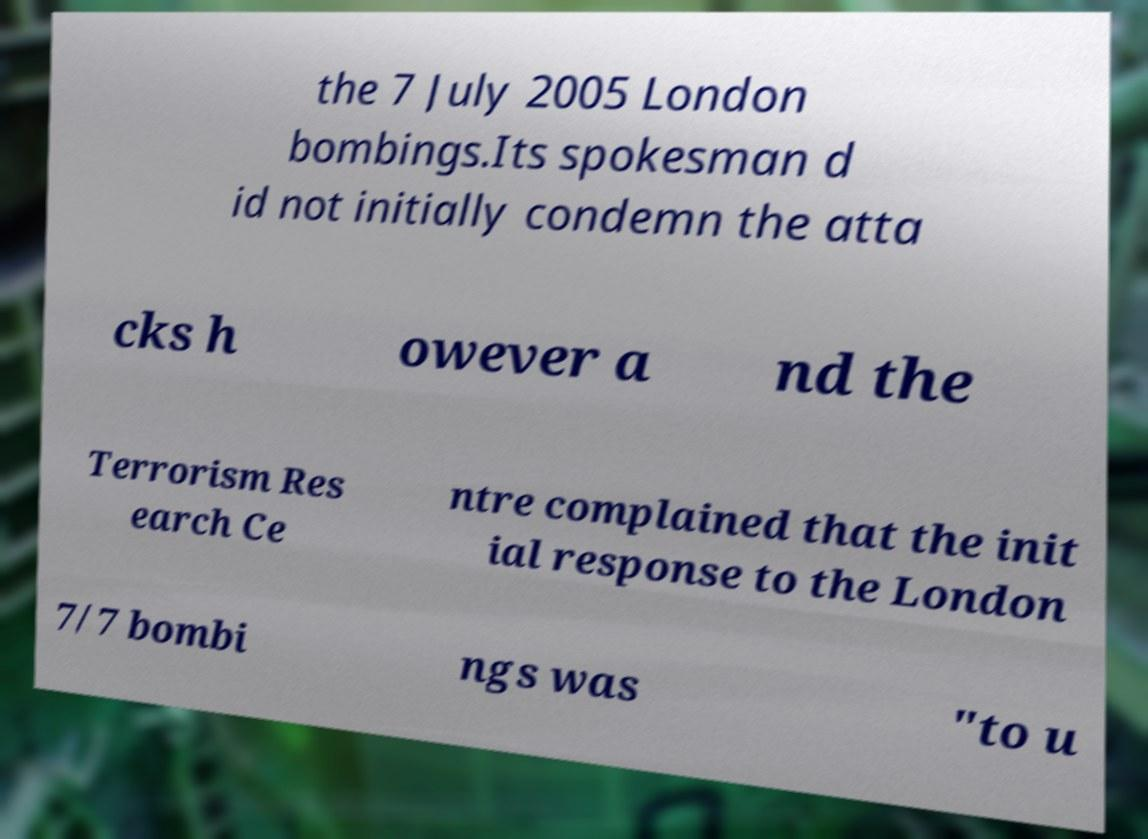For documentation purposes, I need the text within this image transcribed. Could you provide that? the 7 July 2005 London bombings.Its spokesman d id not initially condemn the atta cks h owever a nd the Terrorism Res earch Ce ntre complained that the init ial response to the London 7/7 bombi ngs was "to u 